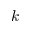<formula> <loc_0><loc_0><loc_500><loc_500>k</formula> 